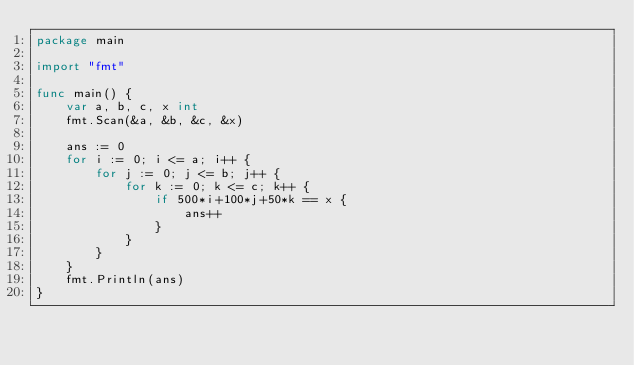<code> <loc_0><loc_0><loc_500><loc_500><_Go_>package main

import "fmt"

func main() {
	var a, b, c, x int
	fmt.Scan(&a, &b, &c, &x)

	ans := 0
	for i := 0; i <= a; i++ {
		for j := 0; j <= b; j++ {
			for k := 0; k <= c; k++ {
				if 500*i+100*j+50*k == x {
					ans++
				}
			}
		}
	}
	fmt.Println(ans)
}
</code> 